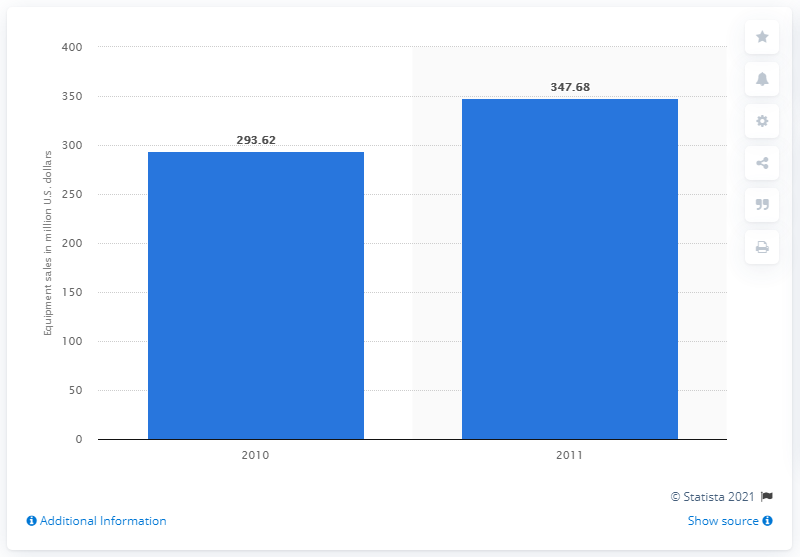Identify some key points in this picture. In 2010, the total sales of lifestyle/travel packs and bags were 293.62 units. 